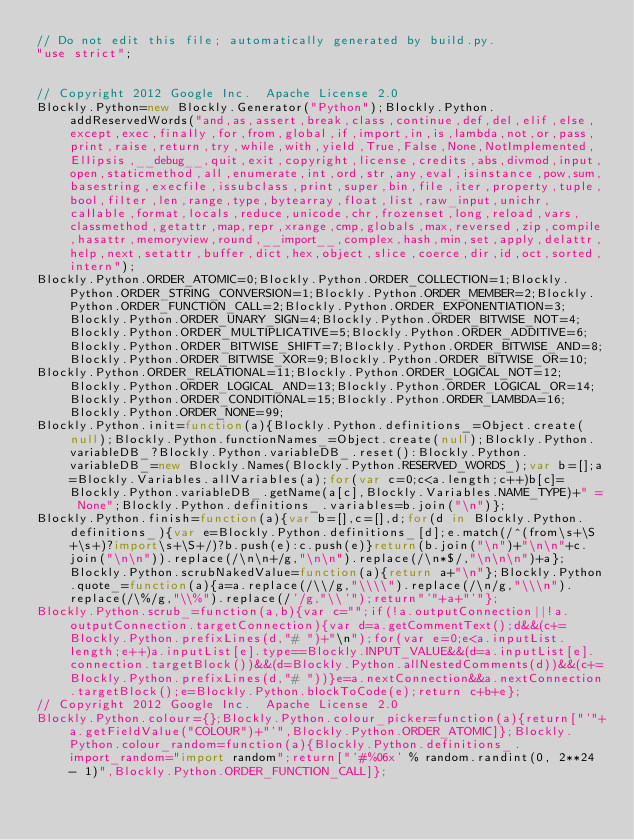<code> <loc_0><loc_0><loc_500><loc_500><_JavaScript_>// Do not edit this file; automatically generated by build.py.
"use strict";


// Copyright 2012 Google Inc.  Apache License 2.0
Blockly.Python=new Blockly.Generator("Python");Blockly.Python.addReservedWords("and,as,assert,break,class,continue,def,del,elif,else,except,exec,finally,for,from,global,if,import,in,is,lambda,not,or,pass,print,raise,return,try,while,with,yield,True,False,None,NotImplemented,Ellipsis,__debug__,quit,exit,copyright,license,credits,abs,divmod,input,open,staticmethod,all,enumerate,int,ord,str,any,eval,isinstance,pow,sum,basestring,execfile,issubclass,print,super,bin,file,iter,property,tuple,bool,filter,len,range,type,bytearray,float,list,raw_input,unichr,callable,format,locals,reduce,unicode,chr,frozenset,long,reload,vars,classmethod,getattr,map,repr,xrange,cmp,globals,max,reversed,zip,compile,hasattr,memoryview,round,__import__,complex,hash,min,set,apply,delattr,help,next,setattr,buffer,dict,hex,object,slice,coerce,dir,id,oct,sorted,intern");
Blockly.Python.ORDER_ATOMIC=0;Blockly.Python.ORDER_COLLECTION=1;Blockly.Python.ORDER_STRING_CONVERSION=1;Blockly.Python.ORDER_MEMBER=2;Blockly.Python.ORDER_FUNCTION_CALL=2;Blockly.Python.ORDER_EXPONENTIATION=3;Blockly.Python.ORDER_UNARY_SIGN=4;Blockly.Python.ORDER_BITWISE_NOT=4;Blockly.Python.ORDER_MULTIPLICATIVE=5;Blockly.Python.ORDER_ADDITIVE=6;Blockly.Python.ORDER_BITWISE_SHIFT=7;Blockly.Python.ORDER_BITWISE_AND=8;Blockly.Python.ORDER_BITWISE_XOR=9;Blockly.Python.ORDER_BITWISE_OR=10;
Blockly.Python.ORDER_RELATIONAL=11;Blockly.Python.ORDER_LOGICAL_NOT=12;Blockly.Python.ORDER_LOGICAL_AND=13;Blockly.Python.ORDER_LOGICAL_OR=14;Blockly.Python.ORDER_CONDITIONAL=15;Blockly.Python.ORDER_LAMBDA=16;Blockly.Python.ORDER_NONE=99;
Blockly.Python.init=function(a){Blockly.Python.definitions_=Object.create(null);Blockly.Python.functionNames_=Object.create(null);Blockly.Python.variableDB_?Blockly.Python.variableDB_.reset():Blockly.Python.variableDB_=new Blockly.Names(Blockly.Python.RESERVED_WORDS_);var b=[];a=Blockly.Variables.allVariables(a);for(var c=0;c<a.length;c++)b[c]=Blockly.Python.variableDB_.getName(a[c],Blockly.Variables.NAME_TYPE)+" = None";Blockly.Python.definitions_.variables=b.join("\n")};
Blockly.Python.finish=function(a){var b=[],c=[],d;for(d in Blockly.Python.definitions_){var e=Blockly.Python.definitions_[d];e.match(/^(from\s+\S+\s+)?import\s+\S+/)?b.push(e):c.push(e)}return(b.join("\n")+"\n\n"+c.join("\n\n")).replace(/\n\n+/g,"\n\n").replace(/\n*$/,"\n\n\n")+a};Blockly.Python.scrubNakedValue=function(a){return a+"\n"};Blockly.Python.quote_=function(a){a=a.replace(/\\/g,"\\\\").replace(/\n/g,"\\\n").replace(/\%/g,"\\%").replace(/'/g,"\\'");return"'"+a+"'"};
Blockly.Python.scrub_=function(a,b){var c="";if(!a.outputConnection||!a.outputConnection.targetConnection){var d=a.getCommentText();d&&(c+=Blockly.Python.prefixLines(d,"# ")+"\n");for(var e=0;e<a.inputList.length;e++)a.inputList[e].type==Blockly.INPUT_VALUE&&(d=a.inputList[e].connection.targetBlock())&&(d=Blockly.Python.allNestedComments(d))&&(c+=Blockly.Python.prefixLines(d,"# "))}e=a.nextConnection&&a.nextConnection.targetBlock();e=Blockly.Python.blockToCode(e);return c+b+e};
// Copyright 2012 Google Inc.  Apache License 2.0
Blockly.Python.colour={};Blockly.Python.colour_picker=function(a){return["'"+a.getFieldValue("COLOUR")+"'",Blockly.Python.ORDER_ATOMIC]};Blockly.Python.colour_random=function(a){Blockly.Python.definitions_.import_random="import random";return["'#%06x' % random.randint(0, 2**24 - 1)",Blockly.Python.ORDER_FUNCTION_CALL]};</code> 